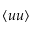Convert formula to latex. <formula><loc_0><loc_0><loc_500><loc_500>\langle u u \rangle</formula> 